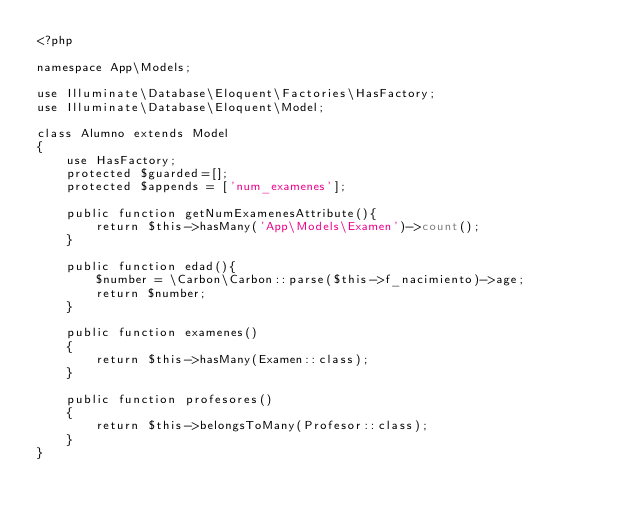<code> <loc_0><loc_0><loc_500><loc_500><_PHP_><?php

namespace App\Models;

use Illuminate\Database\Eloquent\Factories\HasFactory;
use Illuminate\Database\Eloquent\Model;

class Alumno extends Model
{
    use HasFactory;
    protected $guarded=[];
    protected $appends = ['num_examenes'];

    public function getNumExamenesAttribute(){
        return $this->hasMany('App\Models\Examen')->count();
    }

    public function edad(){
        $number = \Carbon\Carbon::parse($this->f_nacimiento)->age;
        return $number;
    }

    public function examenes()
    {
        return $this->hasMany(Examen::class);
    }

    public function profesores()
    {
        return $this->belongsToMany(Profesor::class);
    }
}
</code> 